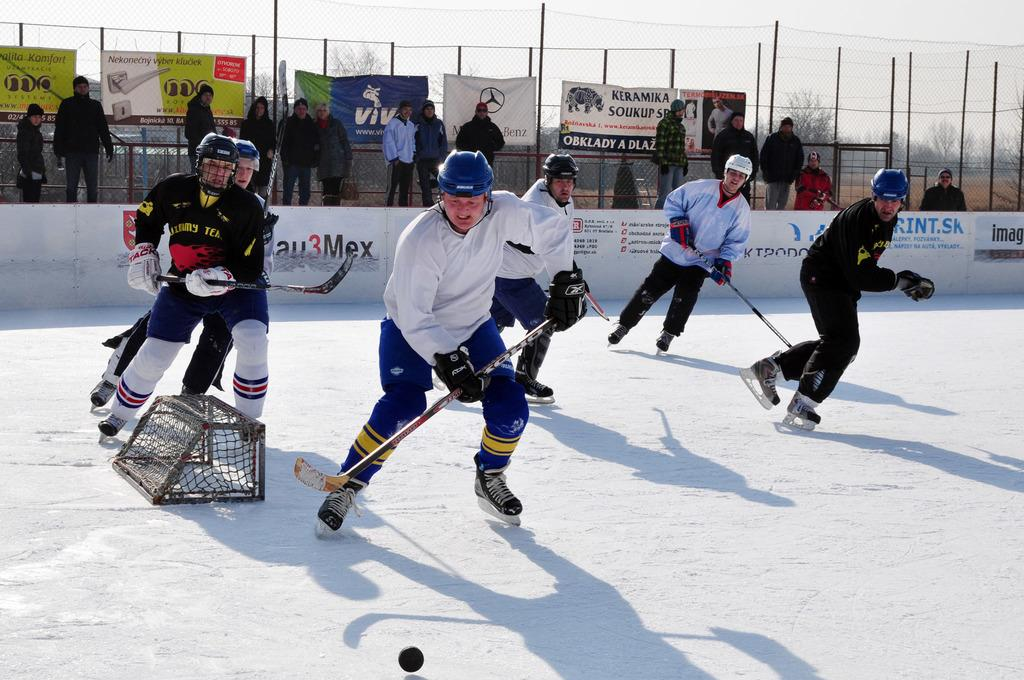How many people are in the image? There is a group of people in the image, but the exact number is not specified. What are the people doing in the image? The people are standing on the ground and holding sticks. What object is present in the image besides the people and sticks? There is a ball in the image. What can be seen in the background of the image? In the background of the image, there are persons, a fence, banners, and poles. What type of rock is being used as a riddle-solving tool in the image? There is no rock present in the image, nor is there any indication of a riddle being solved. 